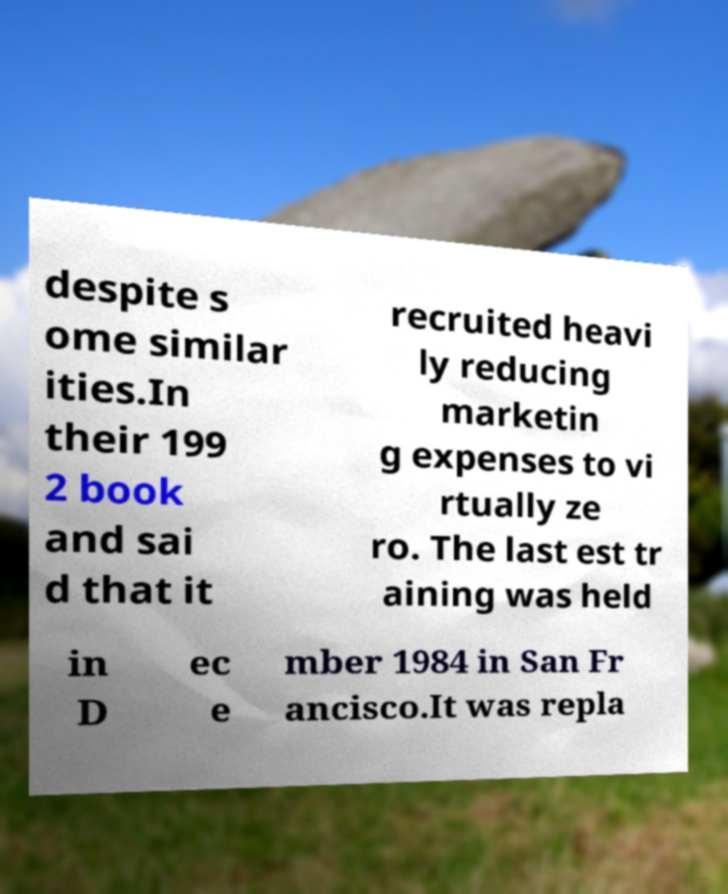For documentation purposes, I need the text within this image transcribed. Could you provide that? despite s ome similar ities.In their 199 2 book and sai d that it recruited heavi ly reducing marketin g expenses to vi rtually ze ro. The last est tr aining was held in D ec e mber 1984 in San Fr ancisco.It was repla 